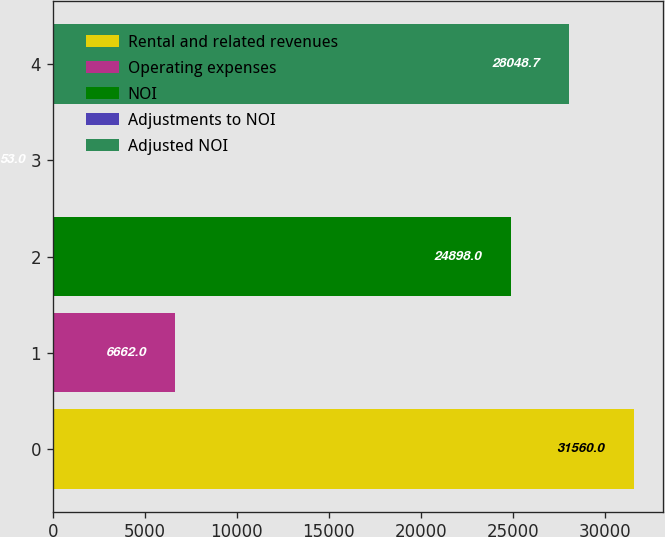<chart> <loc_0><loc_0><loc_500><loc_500><bar_chart><fcel>Rental and related revenues<fcel>Operating expenses<fcel>NOI<fcel>Adjustments to NOI<fcel>Adjusted NOI<nl><fcel>31560<fcel>6662<fcel>24898<fcel>53<fcel>28048.7<nl></chart> 